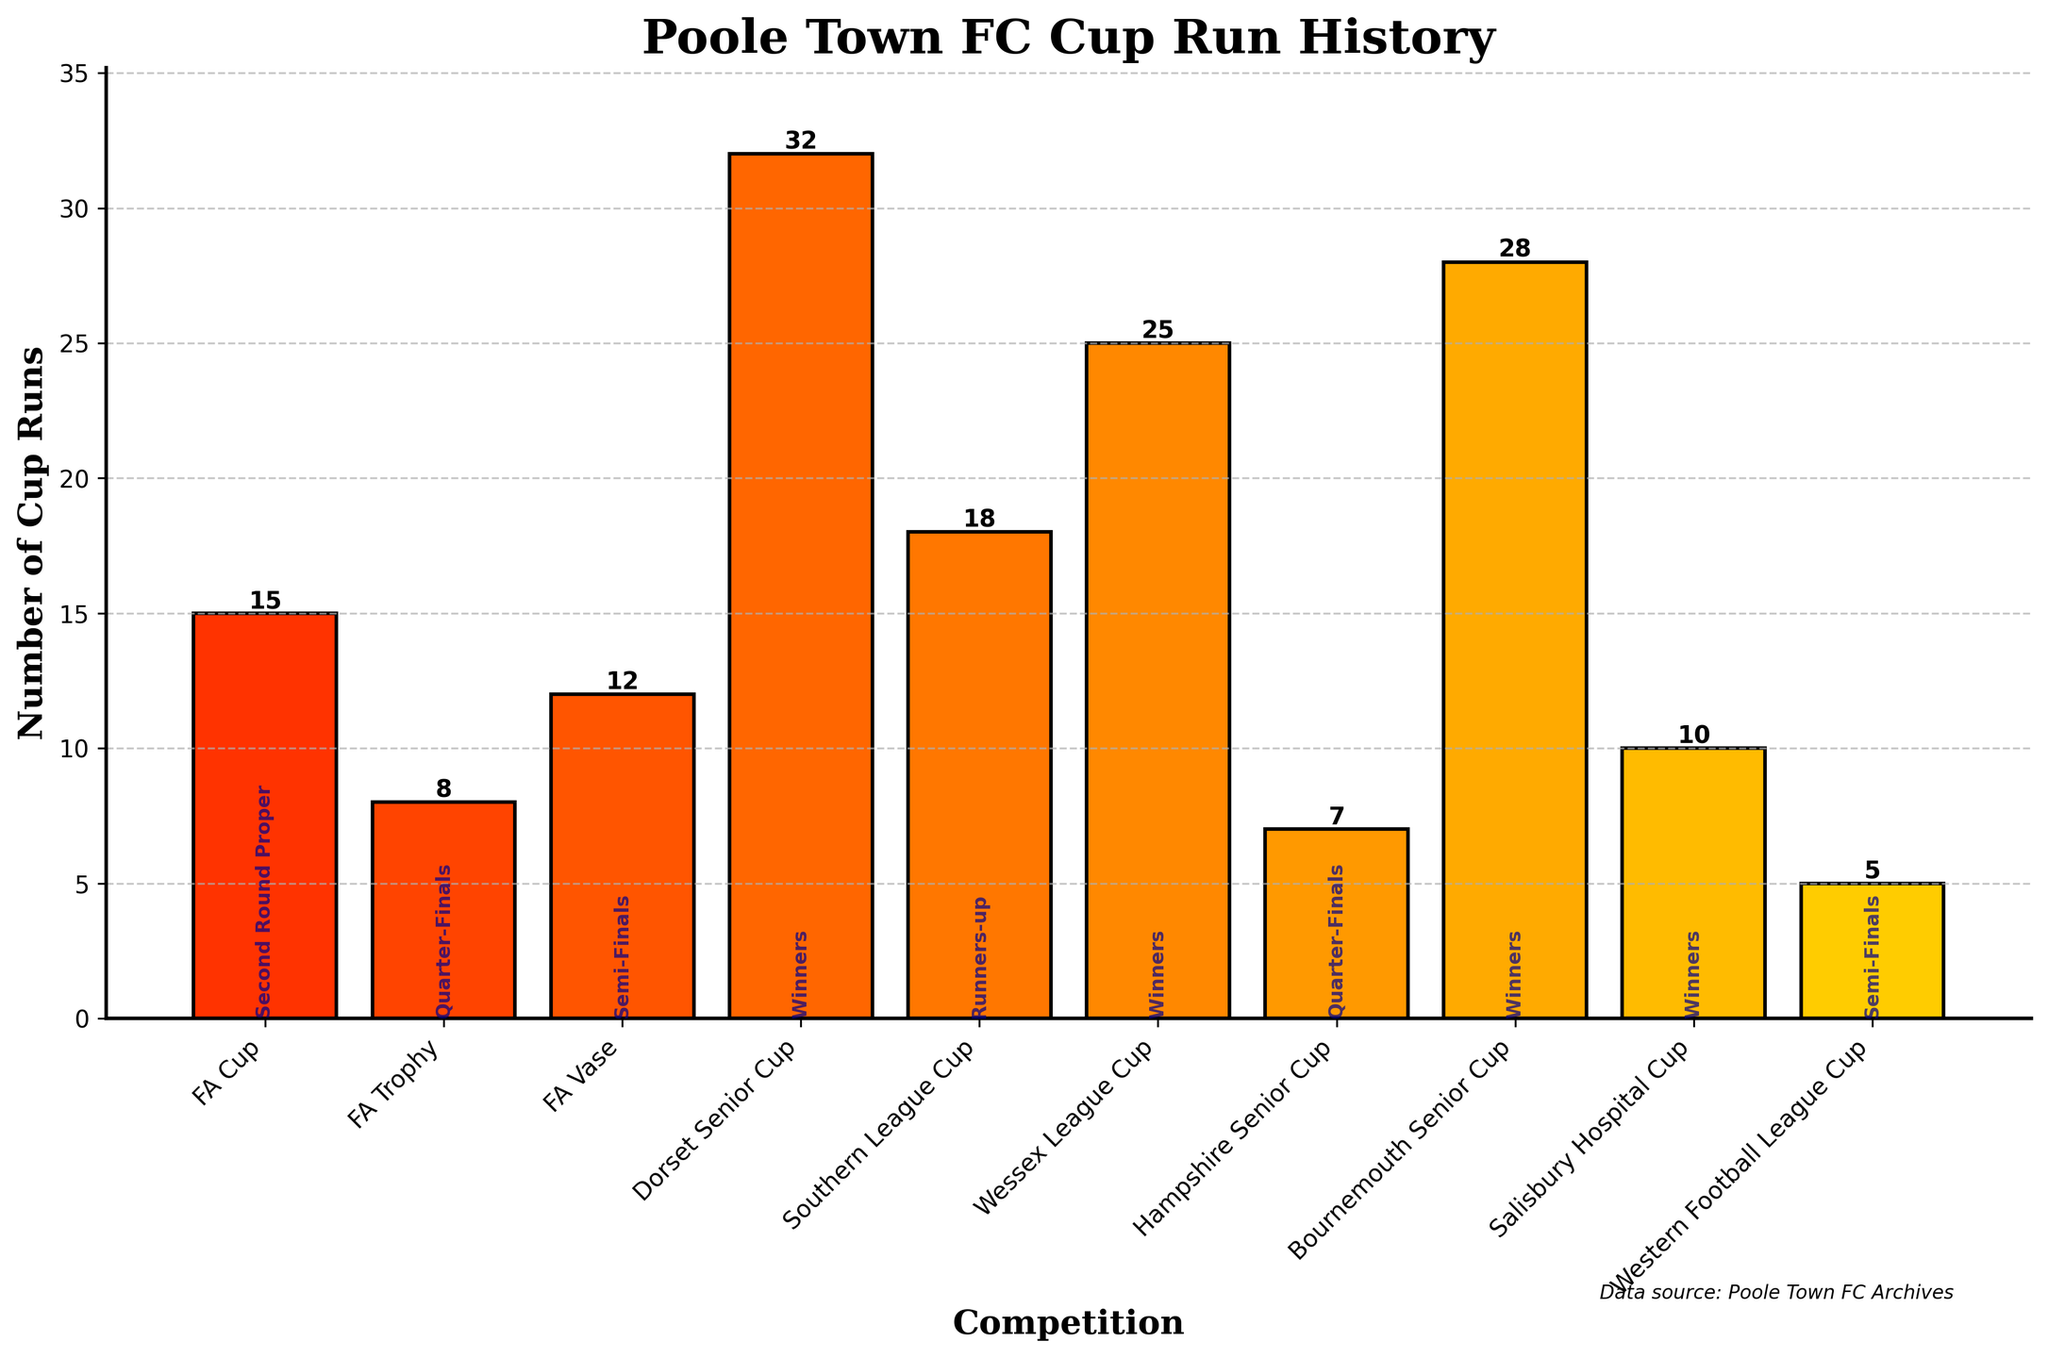Which competition has the most cup runs? By looking at the heights of the bars, the Dorset Senior Cup has the tallest bar indicating the most cup runs with a total of 32 runs.
Answer: Dorset Senior Cup Which competition has the least cup runs? The Western Football League Cup has the shortest bar, indicating the fewest cup runs with a total of 5 runs.
Answer: Western Football League Cup How many more cup runs does the Dorset Senior Cup have compared to the FA Trophy? The Dorset Senior Cup has 32 cup runs while the FA Trophy has 8. The difference is 32 - 8.
Answer: 24 What is the combined number of cup runs for the FA Cup and Wessex League Cup? The FA Cup has 15 cup runs and the Wessex League Cup has 25 cup runs. Adding these gives 15 + 25.
Answer: 40 Which competition has the best performance of "Runners-up"? By checking the text at the bottom of each bar, the Southern League Cup is labeled with "Runners-up".
Answer: Southern League Cup Do more competitions have "Winners" as their best performance compared to "Semi-Finals"? Three competitions (Dorset Senior Cup, Wessex League Cup, Bournemouth Senior Cup, Salisbury Hospital Cup) have "Winners" as their best performance, while two competitions (FA Vase, Western Football League Cup) have "Semi-Finals".
Answer: Yes Which competitions have a best performance of "Quarter-Finals"? The FA Trophy and the Hampshire Senior Cup both have "Quarter-Finals" written at the bottom of their bars.
Answer: FA Trophy, Hampshire Senior Cup Which bar has a color closest to red? Observing the colors, the FA Cup bar is the closest to red due to the autumn color gradient used.
Answer: FA Cup What is the most common best performance among the competitions? By counting the occurrences, "Winners" appears most frequently in the text at the bottom of the bars.
Answer: Winners Which competitions have fewer cup runs than the median number of cup runs? Determining the median of the listed cup runs (sorted order: 5, 7, 8, 10, 12, 15, 18, 25, 28, 32), the median is 15. FA Trophy (8), Hampshire Senior Cup (7), Salisbury Hospital Cup (10), and Western Football League Cup (5) have fewer than 15 cup runs.
Answer: FA Trophy, Hampshire Senior Cup, Salisbury Hospital Cup, Western Football League Cup 